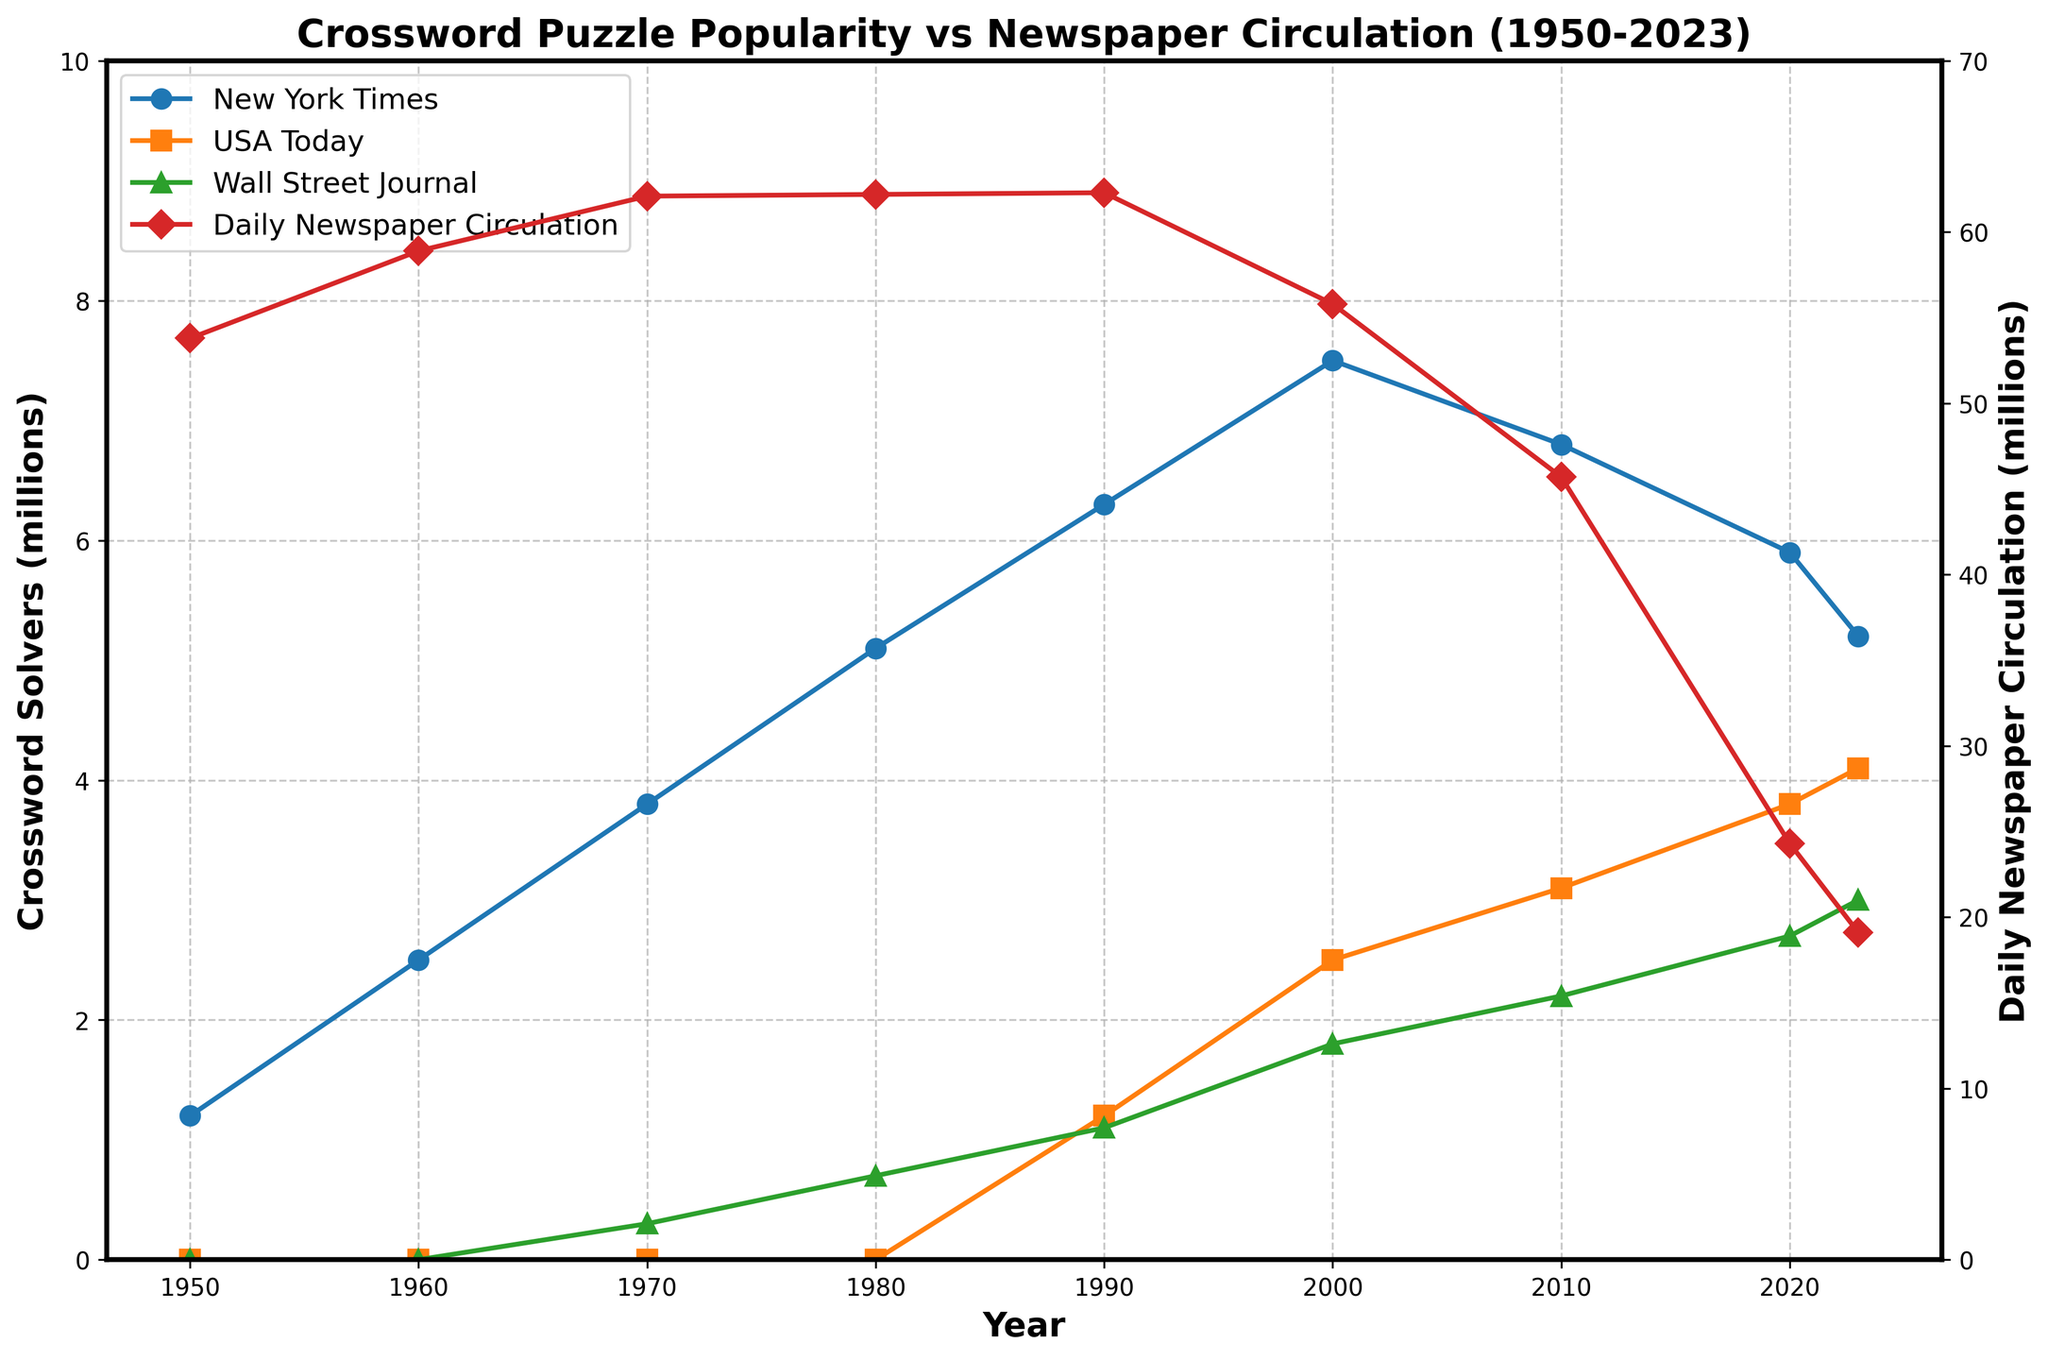What is the trend in New York Times Crossword Solvers from 1950 to 2023? To find the trend, look at the blue line representing the New York Times Crossword Solvers. The line shows an overall increase from 1950 to 2000, reaching a peak of 7.5 million in 2000. However, it declines afterward, dropping to 5.2 million by 2023.
Answer: Overall increasing, then decreasing after 2000 How do the crossword solvers of USA Today compare with those of the Wall Street Journal in 2023? Look at the height of the orange and green markers for USA Today and Wall Street Journal respectively in 2023. USA Today has more solvers (4.1 million) compared to the Wall Street Journal (3.0 million).
Answer: USA Today has 1.1 million more solvers What is the relationship between daily newspaper circulation and New York Times Crossword solvers in 2020? Examine the red line for daily newspaper circulation and the blue line for New York Times Crossword solvers in 2020. The newspaper circulation is 24.3 million, and the number of NYT Crossword solvers is 5.9 million.
Answer: Newspaper circulation: 24.3 million, NYT Crossword solvers: 5.9 million During which decade did the USA Today Crossword Solvers begin appearing in the data? Look at the orange line representing the USA Today Crossword Solvers. It starts appearing on the chart in the 1990s.
Answer: 1990s What is the difference between the peak values of New York Times Crossword solvers and USA Today Crossword solvers? The peak value for the New York Times solvers is 7.5 million (2000), and the peak for USA Today solvers is 4.1 million (2023). The difference is 7.5 - 4.1 = 3.4 million.
Answer: 3.4 million What color lines are used to represent the Wall Street Journal and daily newspaper circulation? Identify the lines on the chart. The Wall Street Journal is represented by a green line, and daily newspaper circulation is represented by a red line.
Answer: Green for Wall Street Journal, red for daily newspaper circulation In which year was the daily newspaper circulation the highest, and what was the value? Look at the red line representing daily newspaper circulation. It peaks in 1990 at 62.3 million.
Answer: 1990, 62.3 million What is the average number of New York Times Crossword Solvers over the 1950-2023 period? Sum up the values for New York Times Crossword Solvers (1.2, 2.5, 3.8, 5.1, 6.3, 7.5, 6.8, 5.9, 5.2) and divide by the number of years (9). The average is (1.2+2.5+3.8+5.1+6.3+7.5+6.8+5.9+5.2)/9 = 44.3/9 ≈ 4.92 million.
Answer: 4.92 million 